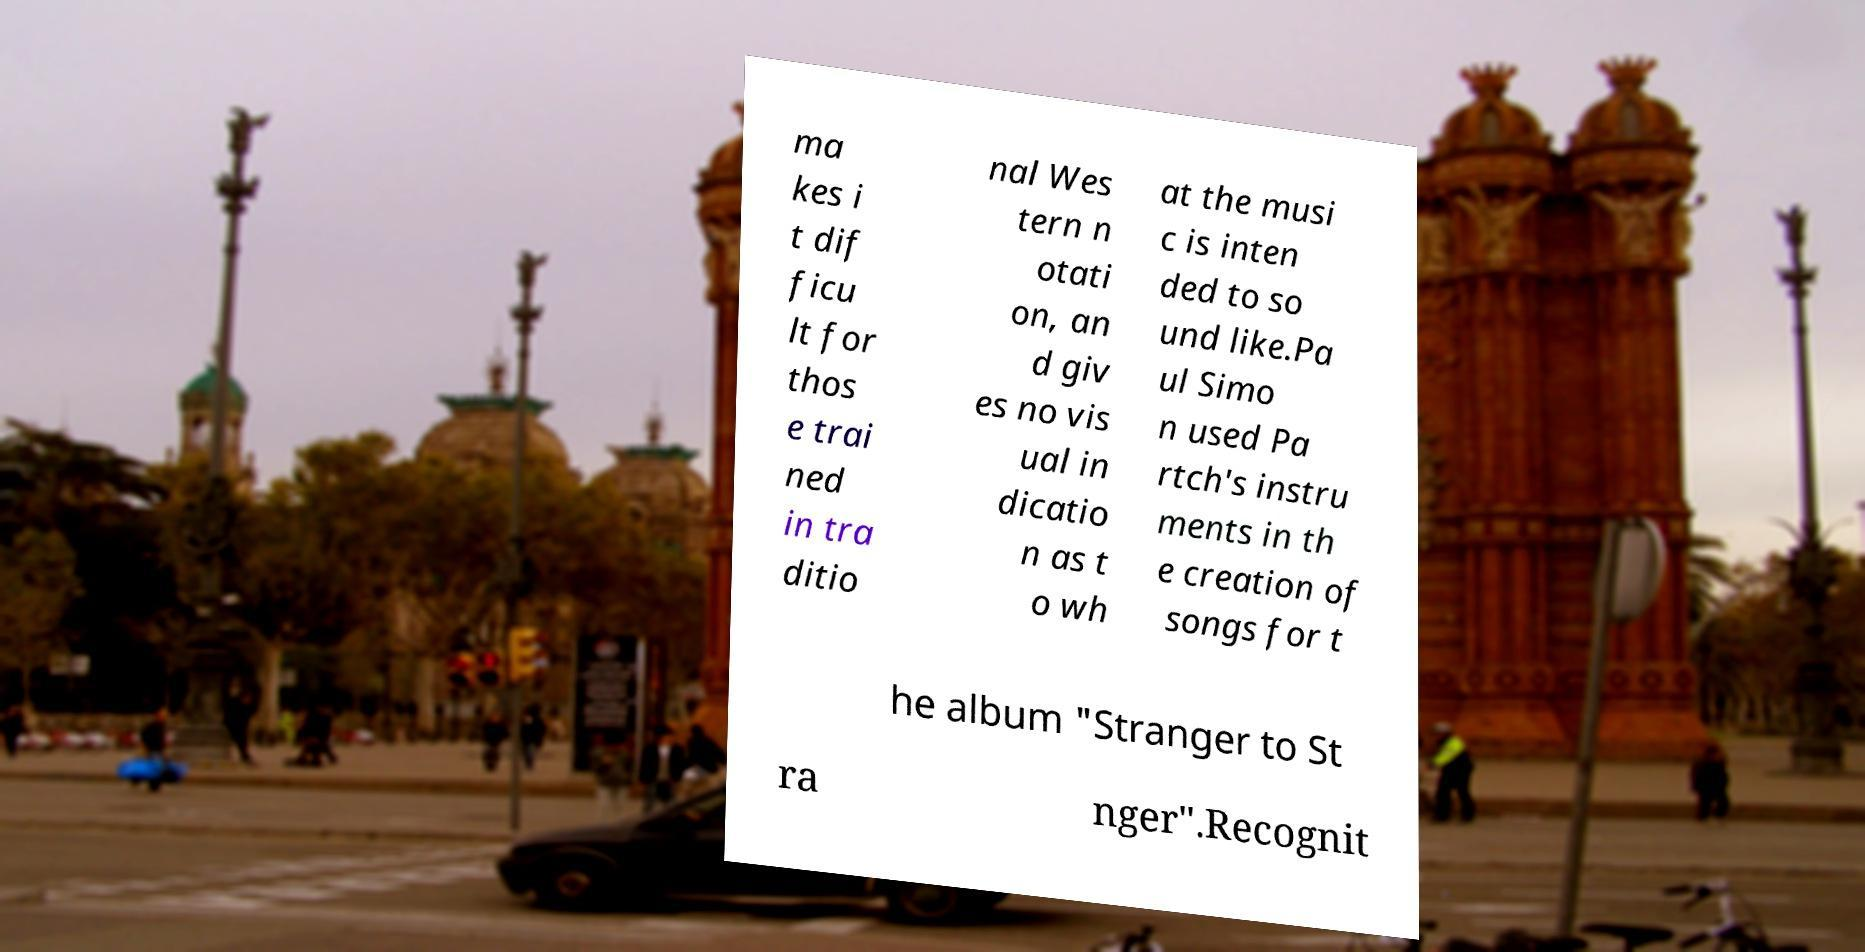Please identify and transcribe the text found in this image. ma kes i t dif ficu lt for thos e trai ned in tra ditio nal Wes tern n otati on, an d giv es no vis ual in dicatio n as t o wh at the musi c is inten ded to so und like.Pa ul Simo n used Pa rtch's instru ments in th e creation of songs for t he album "Stranger to St ra nger".Recognit 